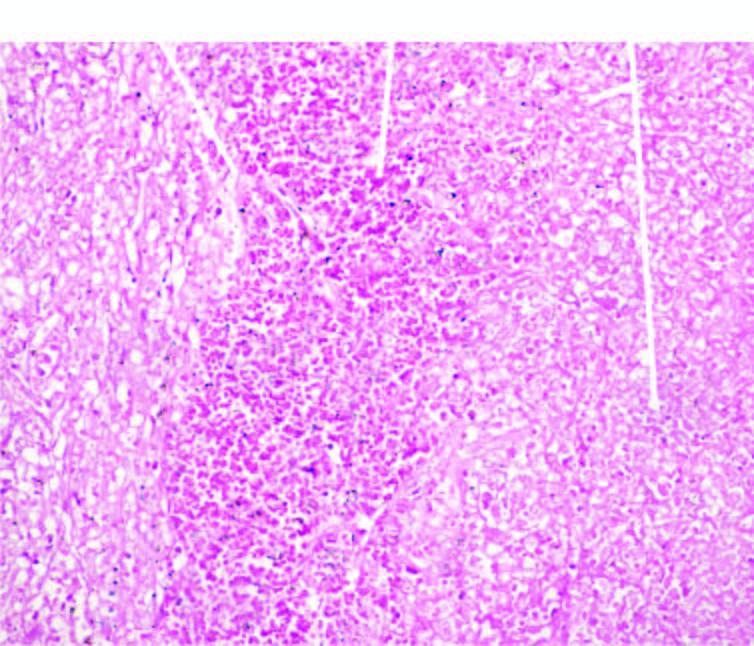what shows outlines of cells only due to coagulative necrosis while the margin of infracted area shows haemorrhage?
Answer the question using a single word or phrase. The affected area 